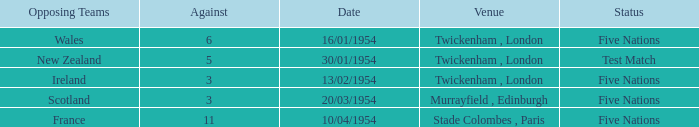In which venue was there an against of 11? Stade Colombes , Paris. Would you mind parsing the complete table? {'header': ['Opposing Teams', 'Against', 'Date', 'Venue', 'Status'], 'rows': [['Wales', '6', '16/01/1954', 'Twickenham , London', 'Five Nations'], ['New Zealand', '5', '30/01/1954', 'Twickenham , London', 'Test Match'], ['Ireland', '3', '13/02/1954', 'Twickenham , London', 'Five Nations'], ['Scotland', '3', '20/03/1954', 'Murrayfield , Edinburgh', 'Five Nations'], ['France', '11', '10/04/1954', 'Stade Colombes , Paris', 'Five Nations']]} 